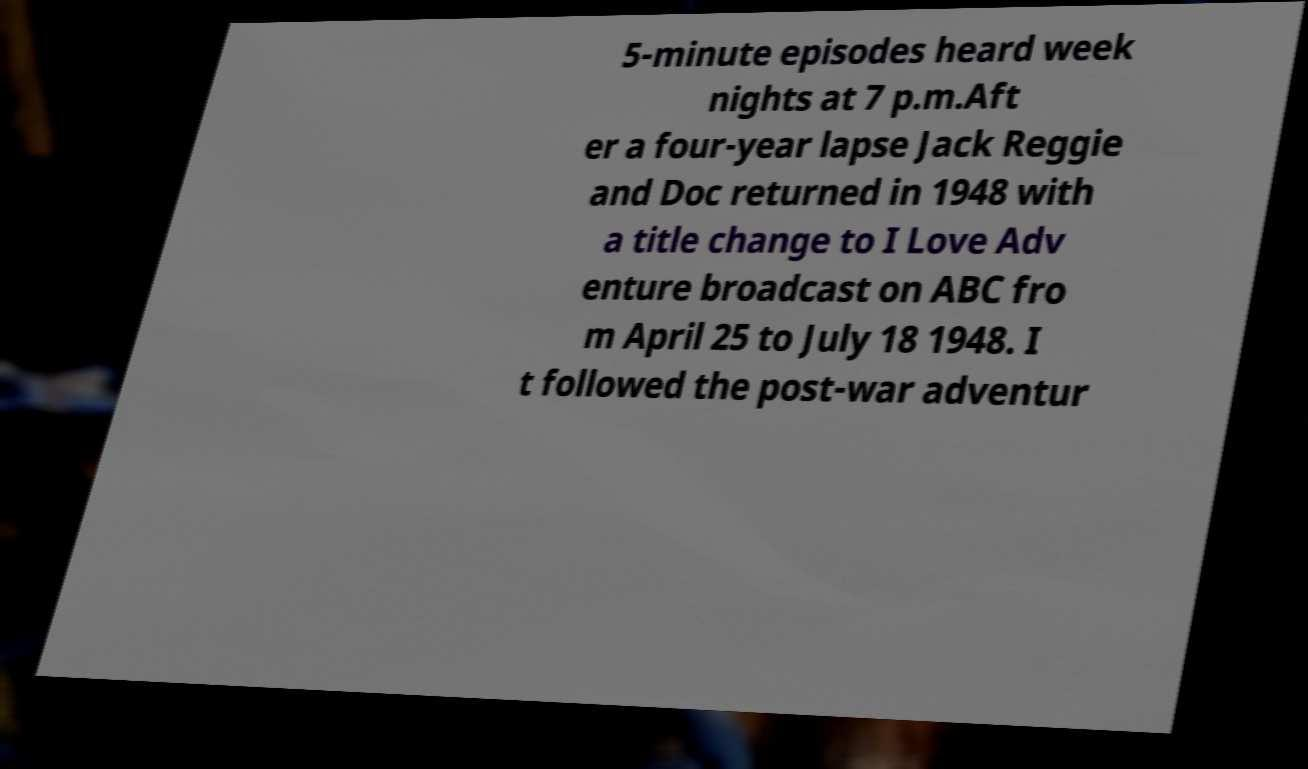I need the written content from this picture converted into text. Can you do that? 5-minute episodes heard week nights at 7 p.m.Aft er a four-year lapse Jack Reggie and Doc returned in 1948 with a title change to I Love Adv enture broadcast on ABC fro m April 25 to July 18 1948. I t followed the post-war adventur 